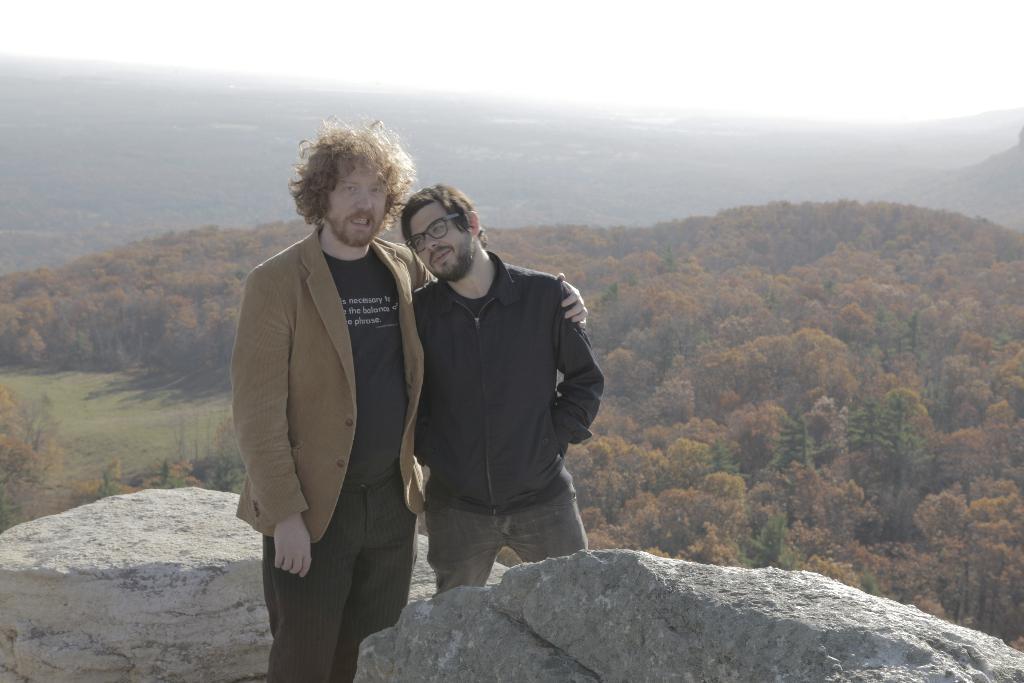Can you describe this image briefly? In the foreground of this picture, there are two men standing in between two rocks. In the background, we can see trees, mountains and the white shade on the top. 